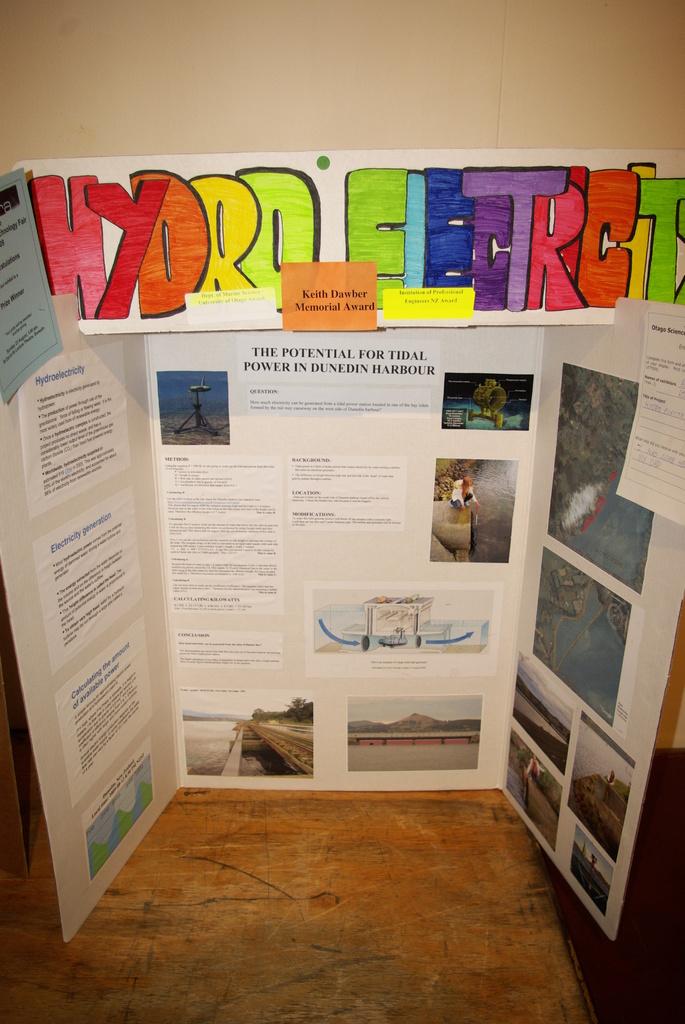What's the name of the award keith dawber received?
Your response must be concise. Memorial award. What is the title of this science fair project?
Make the answer very short. Hydro electricity. 